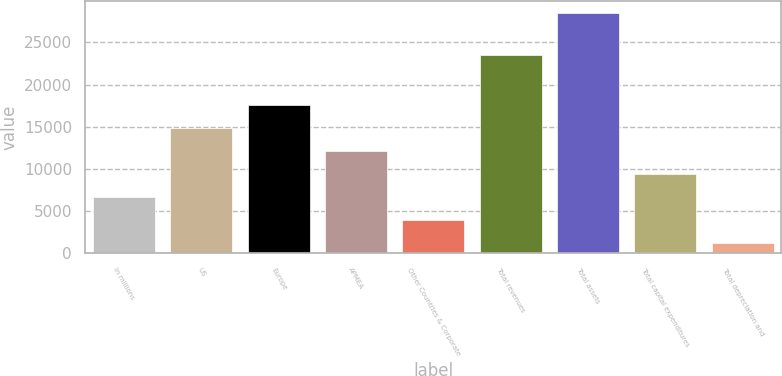Convert chart. <chart><loc_0><loc_0><loc_500><loc_500><bar_chart><fcel>In millions<fcel>US<fcel>Europe<fcel>APMEA<fcel>Other Countries & Corporate<fcel>Total revenues<fcel>Total assets<fcel>Total capital expenditures<fcel>Total depreciation and<nl><fcel>6658.54<fcel>14834.6<fcel>17560<fcel>12109.3<fcel>3933.17<fcel>23522.4<fcel>28461.5<fcel>9383.91<fcel>1207.8<nl></chart> 